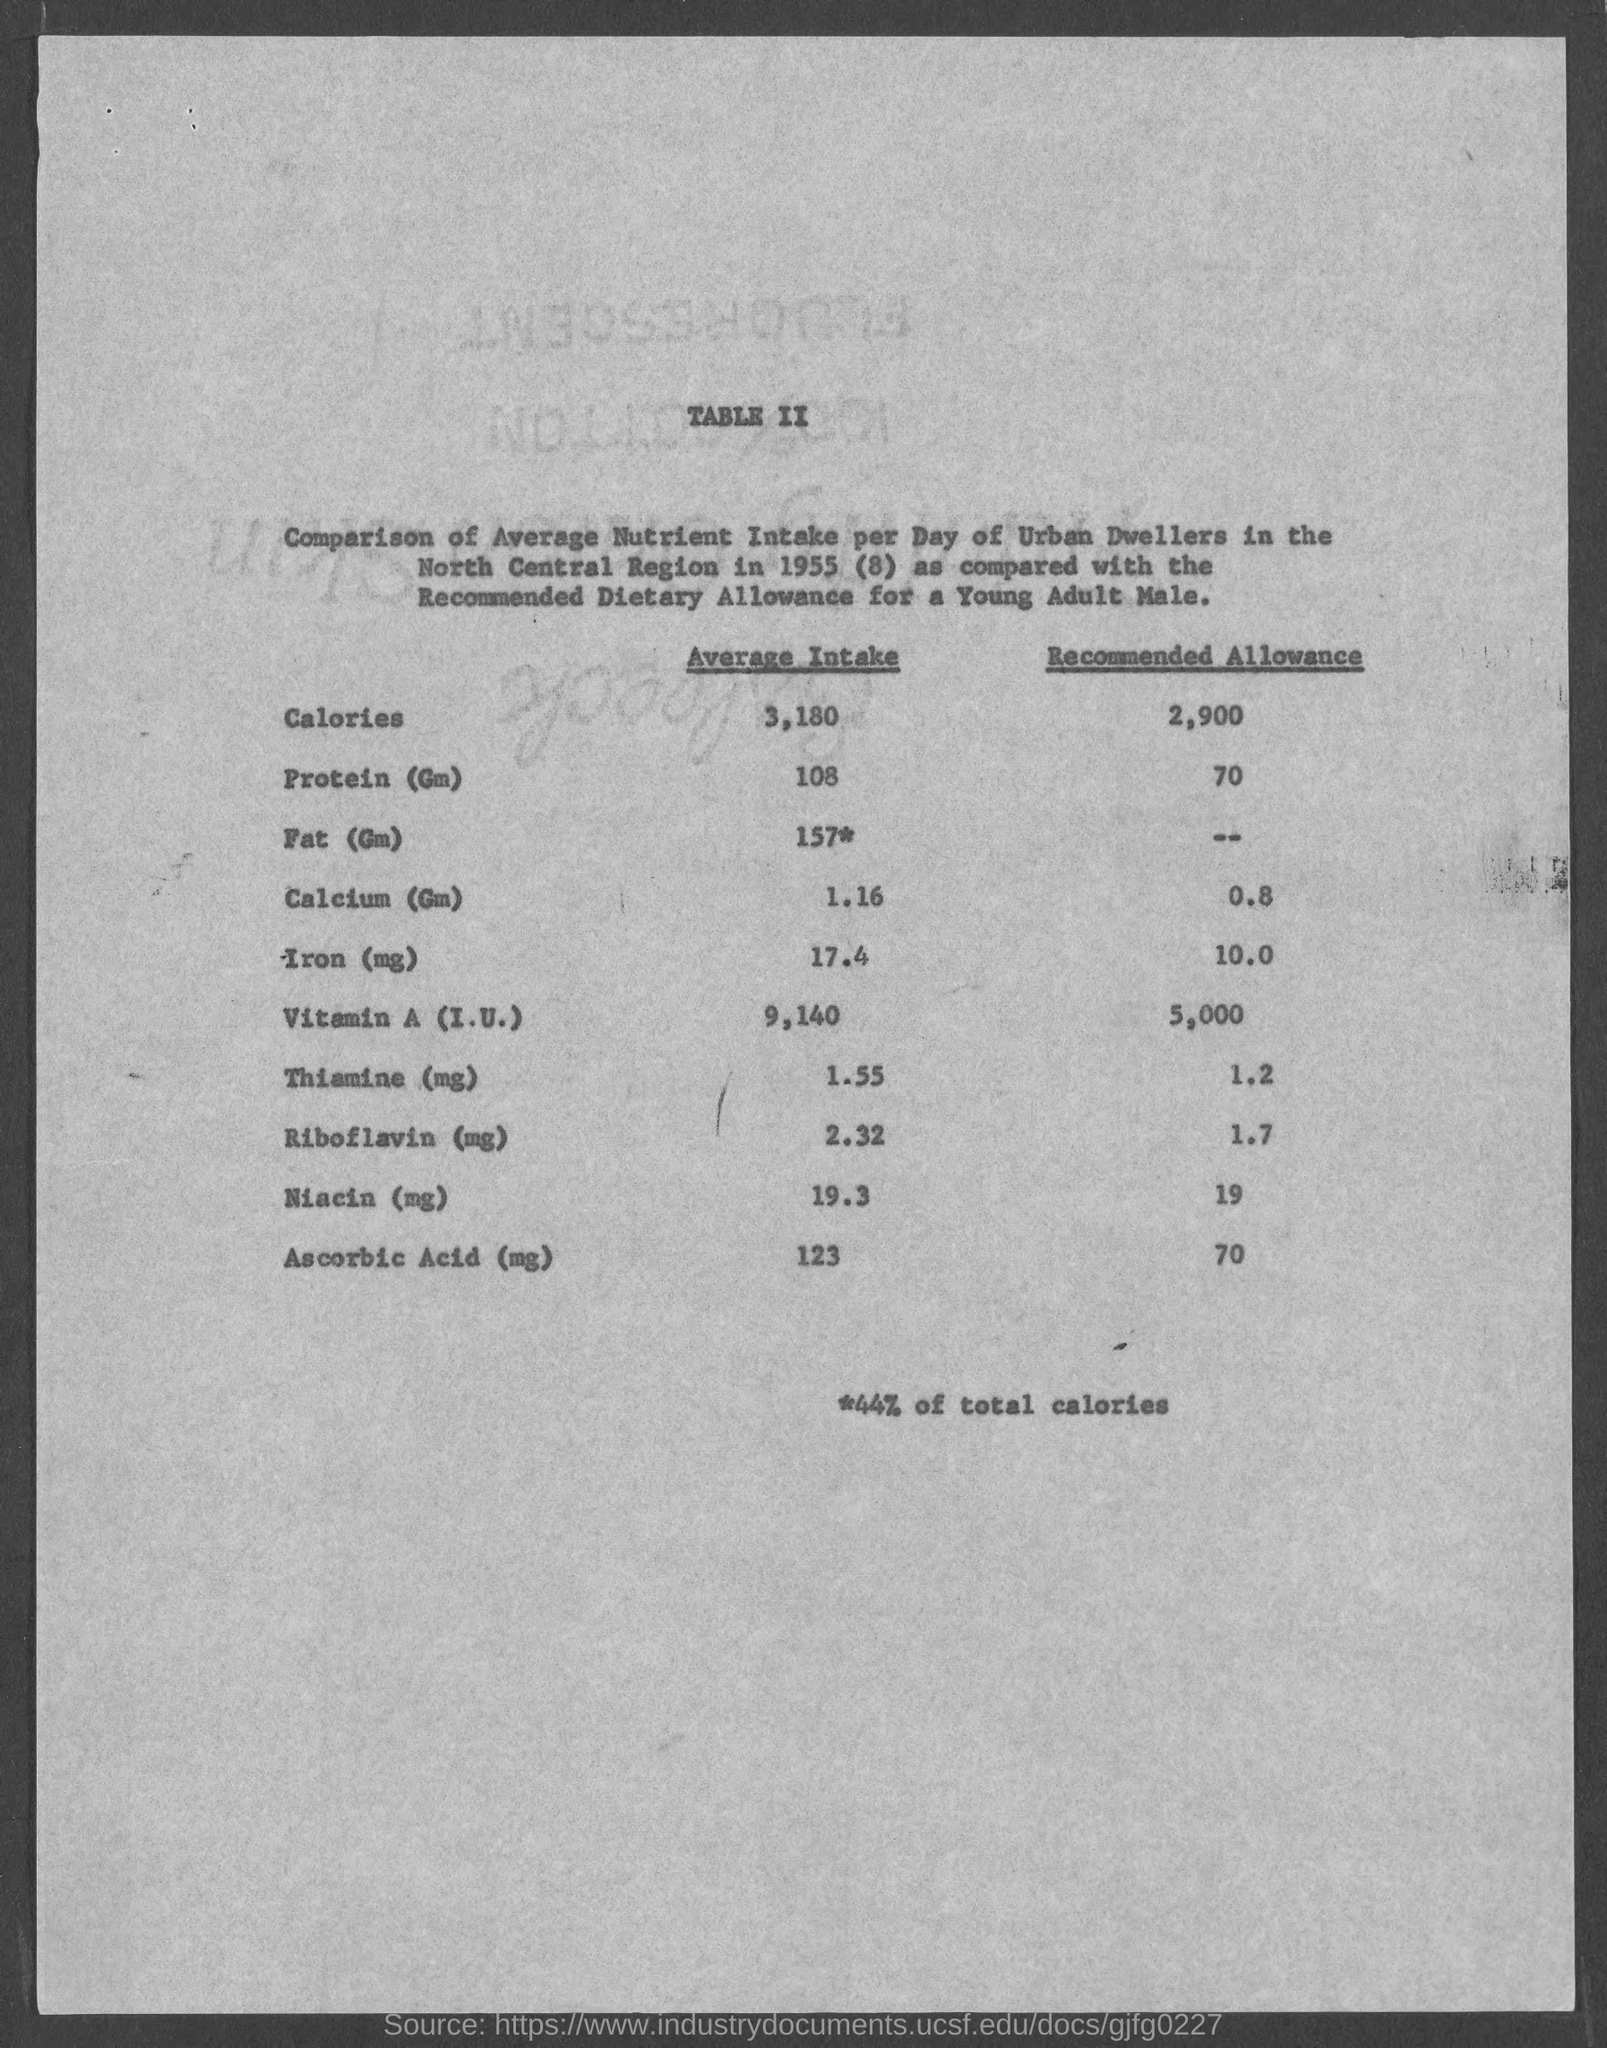What is the average intake of calories ?
Give a very brief answer. 3,180. What is the recommended allowance of calories ?
Offer a very short reply. 2900. What is the average intake of protein (gm)?
Provide a succinct answer. 108. What is the average intake of fat (gm)
Your response must be concise. 157* gm. What is the average intake of calcium (gm)
Give a very brief answer. 1.16 gm. What is the average intake of iron (mg)?
Offer a very short reply. 17.4 mg. What is the average intake of thiamine (mg)?
Give a very brief answer. 1.55 mg. What is the average intake of riboflavin (mg)
Offer a very short reply. 2.32. What is the average intake of niacin (mg)
Provide a short and direct response. 19.3. What is the average intake of ascorbic acid(mg)
Your answer should be very brief. 123 mg. 